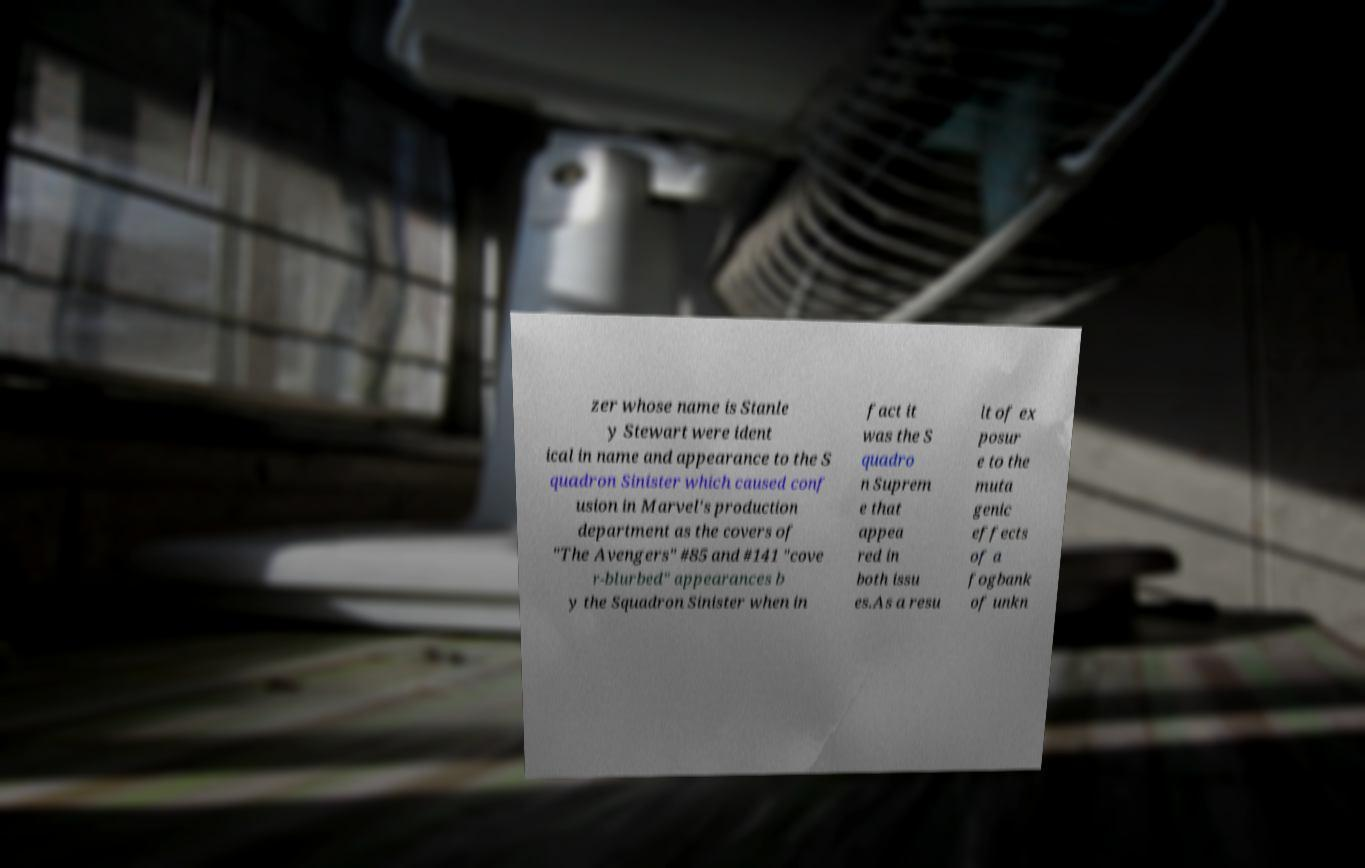Can you accurately transcribe the text from the provided image for me? zer whose name is Stanle y Stewart were ident ical in name and appearance to the S quadron Sinister which caused conf usion in Marvel's production department as the covers of "The Avengers" #85 and #141 "cove r-blurbed" appearances b y the Squadron Sinister when in fact it was the S quadro n Suprem e that appea red in both issu es.As a resu lt of ex posur e to the muta genic effects of a fogbank of unkn 